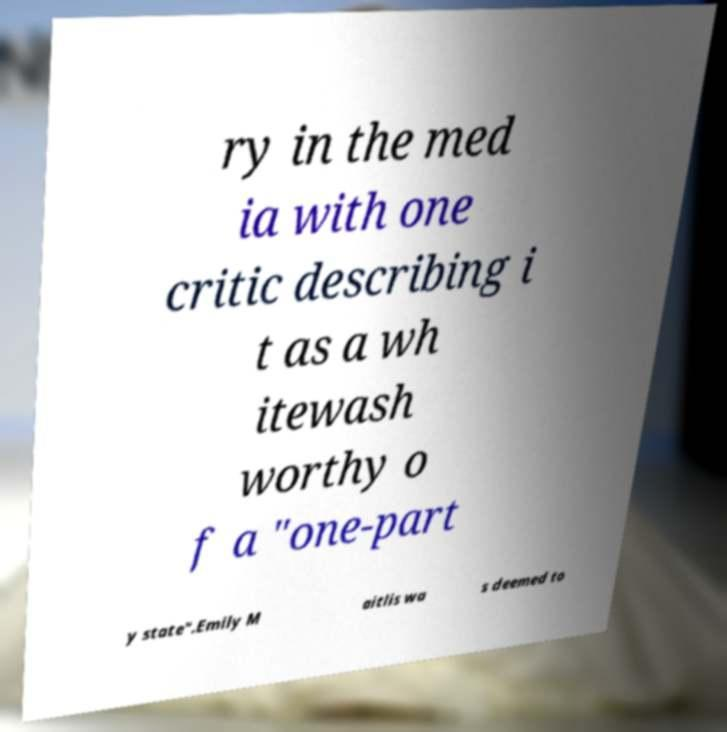Can you read and provide the text displayed in the image?This photo seems to have some interesting text. Can you extract and type it out for me? ry in the med ia with one critic describing i t as a wh itewash worthy o f a "one-part y state".Emily M aitlis wa s deemed to 